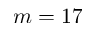<formula> <loc_0><loc_0><loc_500><loc_500>m = 1 7</formula> 